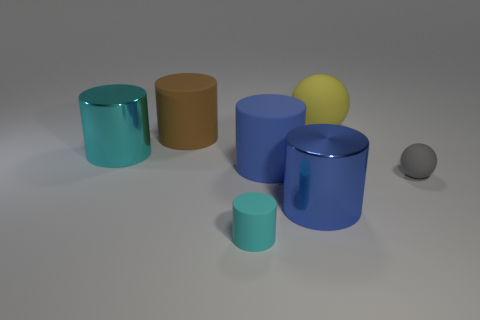Are any tiny green matte cubes visible?
Your response must be concise. No. There is a metallic object that is in front of the gray sphere; what number of cyan rubber things are behind it?
Offer a terse response. 0. What shape is the thing on the right side of the big yellow rubber object?
Offer a very short reply. Sphere. What material is the cyan cylinder in front of the cyan cylinder that is left of the tiny matte thing that is to the left of the gray matte ball made of?
Provide a short and direct response. Rubber. What number of other objects are there of the same size as the cyan rubber cylinder?
Keep it short and to the point. 1. There is a large brown thing that is the same shape as the cyan matte thing; what is it made of?
Keep it short and to the point. Rubber. What is the color of the tiny ball?
Ensure brevity in your answer.  Gray. The shiny object left of the cylinder on the right side of the blue matte cylinder is what color?
Offer a terse response. Cyan. Does the tiny matte cylinder have the same color as the large shiny cylinder that is to the right of the small cyan object?
Give a very brief answer. No. There is a shiny cylinder to the left of the shiny cylinder in front of the large blue matte thing; what number of cyan matte cylinders are behind it?
Your answer should be compact. 0. 